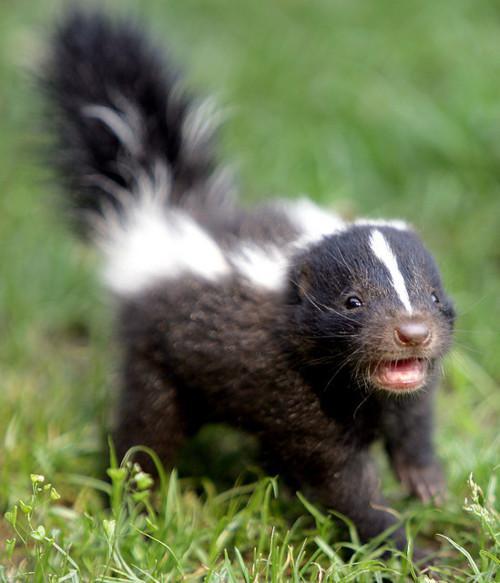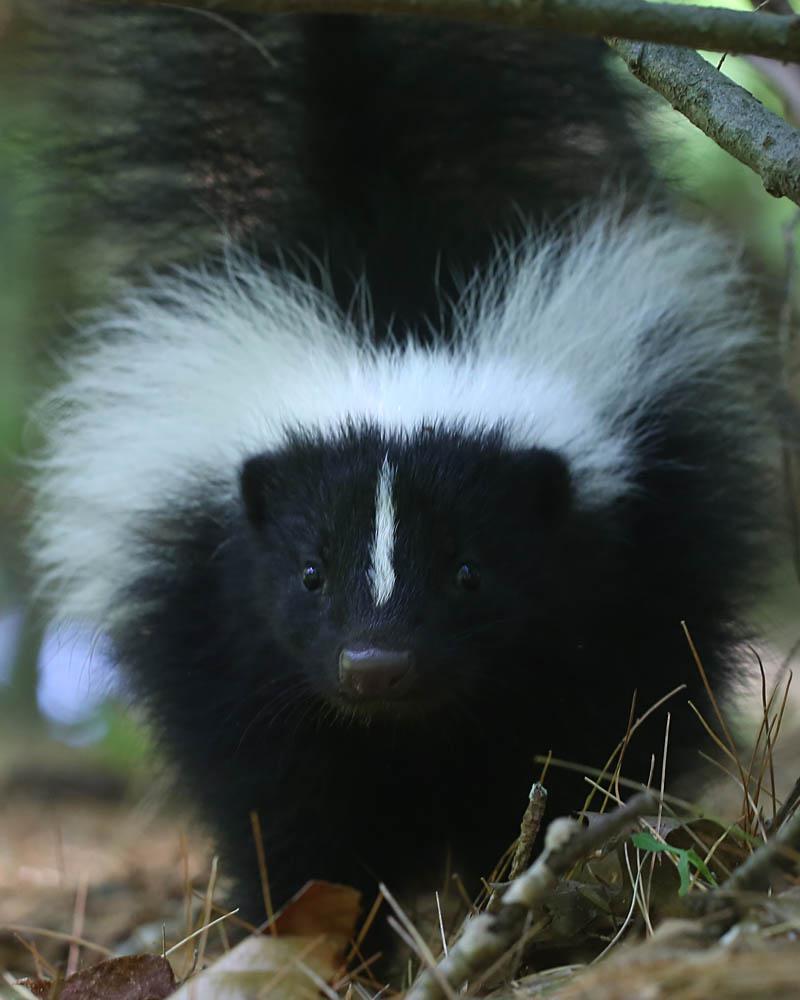The first image is the image on the left, the second image is the image on the right. Evaluate the accuracy of this statement regarding the images: "Two skunks are visible.". Is it true? Answer yes or no. Yes. The first image is the image on the left, the second image is the image on the right. For the images displayed, is the sentence "Left and right images do not contain the same number of skunks, and the left image contains at least one leftward angled skunk with an upright tail." factually correct? Answer yes or no. No. 